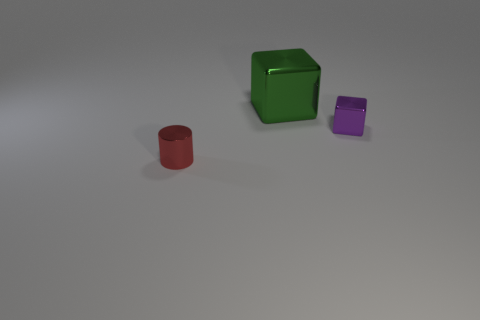Is the number of tiny red shiny cylinders greater than the number of small brown rubber cubes?
Provide a short and direct response. Yes. Are there any small cylinders that have the same color as the big thing?
Provide a short and direct response. No. There is a metallic cube on the right side of the green thing; does it have the same size as the red shiny cylinder?
Your answer should be very brief. Yes. Are there fewer tiny gray matte cubes than purple shiny things?
Make the answer very short. Yes. Are there any big blue cylinders that have the same material as the big green thing?
Keep it short and to the point. No. The tiny thing that is right of the green cube has what shape?
Give a very brief answer. Cube. Do the small shiny object in front of the purple shiny cube and the big metallic thing have the same color?
Provide a short and direct response. No. Is the number of big green things behind the metallic cylinder less than the number of green cubes?
Provide a short and direct response. No. There is a cylinder that is made of the same material as the green block; what color is it?
Ensure brevity in your answer.  Red. What is the size of the shiny thing in front of the small cube?
Give a very brief answer. Small. 